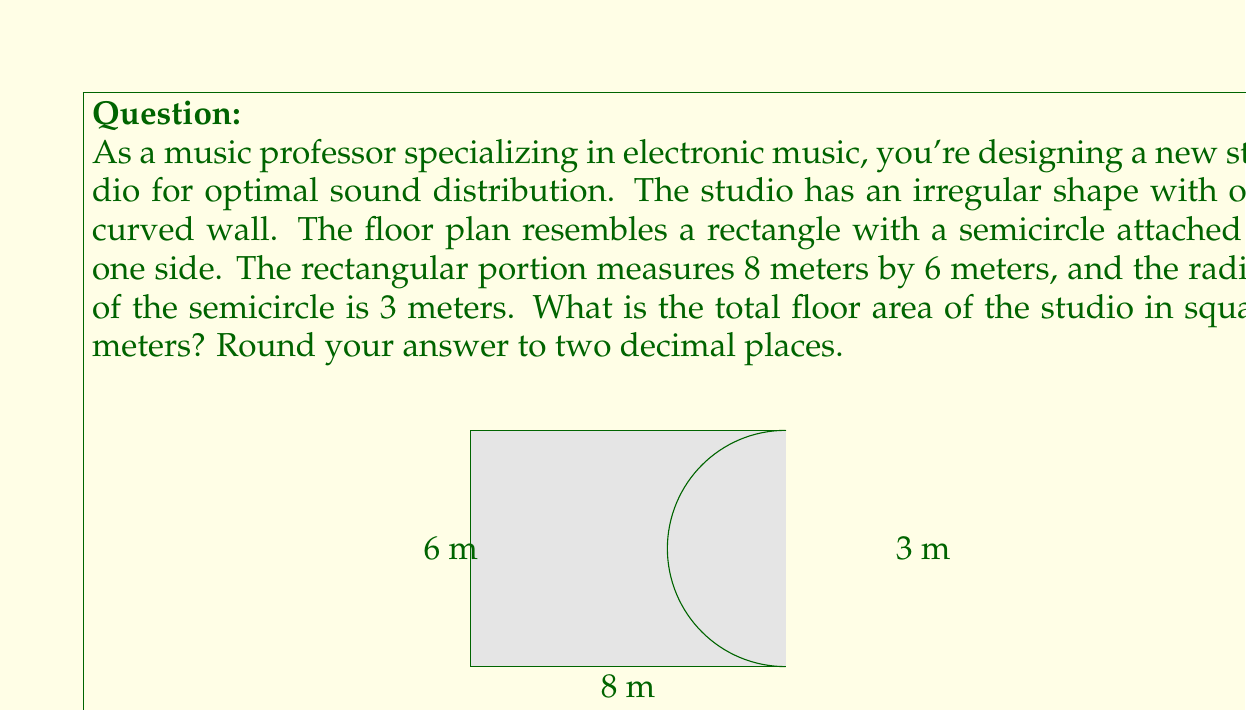Help me with this question. To solve this problem, we need to break it down into two parts: the area of the rectangle and the area of the semicircle.

1. Area of the rectangle:
   $$A_r = l \times w = 8 \text{ m} \times 6 \text{ m} = 48 \text{ m}^2$$

2. Area of the semicircle:
   The area of a full circle is $\pi r^2$, so the area of a semicircle is half of that.
   $$A_s = \frac{1}{2} \pi r^2 = \frac{1}{2} \pi (3 \text{ m})^2 = \frac{9\pi}{2} \text{ m}^2$$

3. Total area:
   $$A_{\text{total}} = A_r + A_s = 48 \text{ m}^2 + \frac{9\pi}{2} \text{ m}^2$$

4. Calculating the final result:
   $$A_{\text{total}} = 48 + \frac{9 \times 3.14159}{2} \approx 62.12 \text{ m}^2$$

Rounding to two decimal places, we get 62.12 m².

This calculation allows for precise speaker placement by knowing the exact floor area, which is crucial for optimizing sound distribution in the studio.
Answer: 62.12 m² 